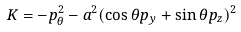Convert formula to latex. <formula><loc_0><loc_0><loc_500><loc_500>K = - p _ { \theta } ^ { 2 } - a ^ { 2 } ( \cos \theta p _ { y } + \sin \theta p _ { z } ) ^ { 2 }</formula> 